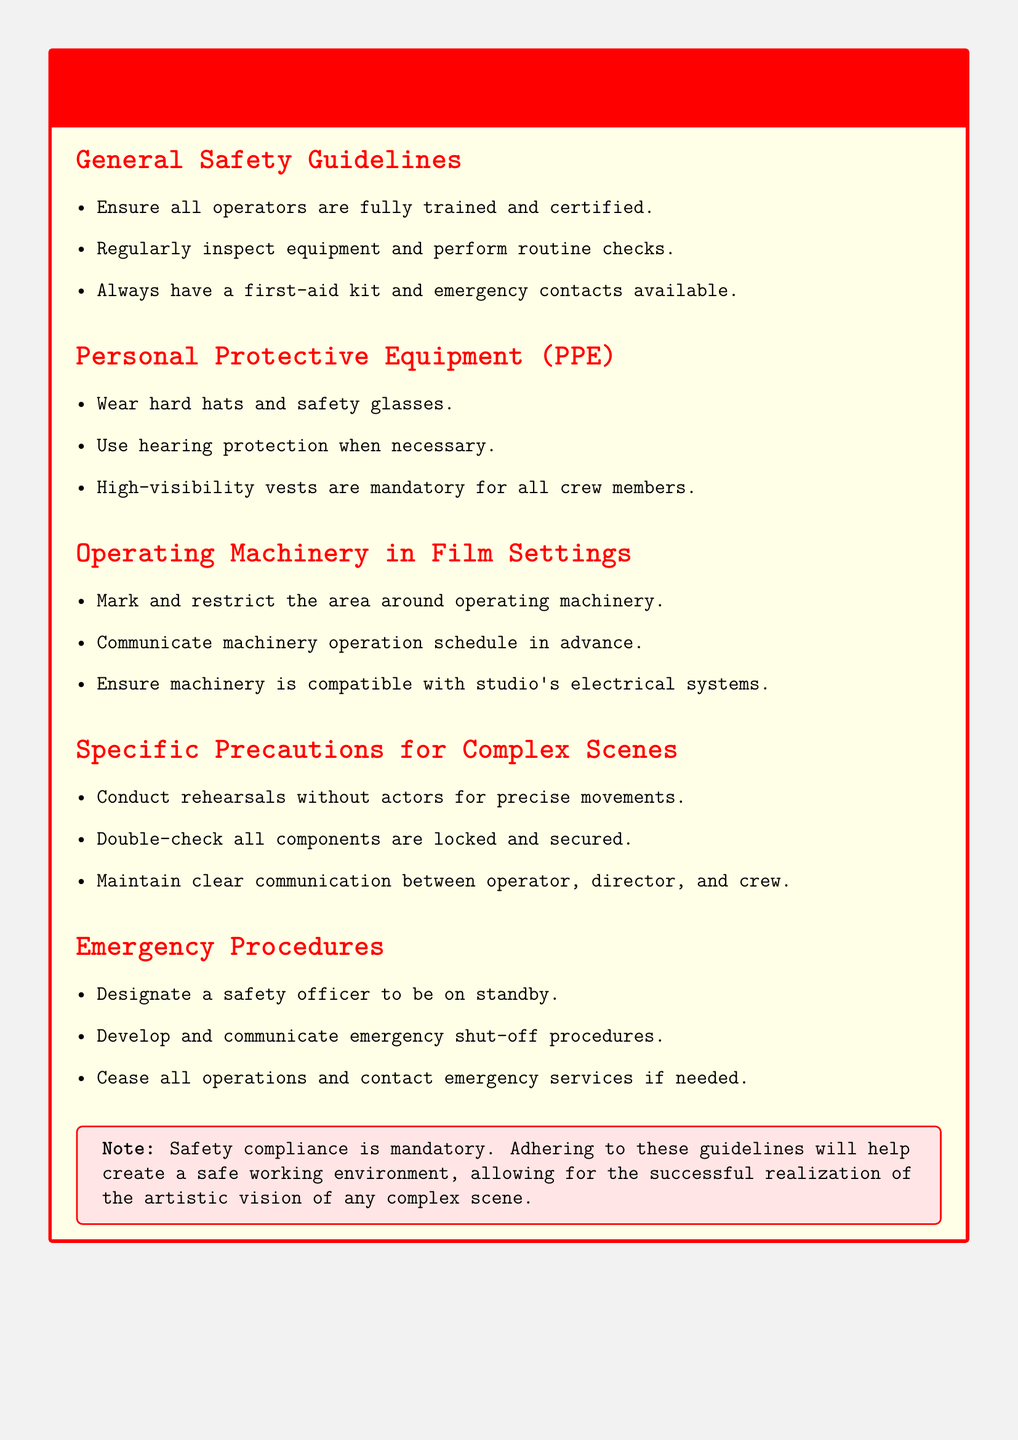what is the color of the warning box title? The title of the warning box is in red color, as stated in the document’s formatting.
Answer: red how many general safety guidelines are listed? The document lists three general safety guidelines in the relevant section.
Answer: 3 what type of protective equipment is mandatory for crew members? The document specifies high-visibility vests as mandatory for all crew members.
Answer: high-visibility vests who should be on standby in emergency procedures? The document states that a safety officer should be designated to be on standby.
Answer: safety officer what should operators ensure about machinery's compatibility? Operators should ensure that machinery is compatible with the studio's electrical systems.
Answer: compatible with studio's electrical systems what is a critical action to take during complex scene preparations? The document emphasizes the importance of conducting rehearsals without actors for precise movements.
Answer: rehearsals without actors how is communication supposed to be maintained among crew during operations? The document advises maintaining clear communication between the operator, director, and crew.
Answer: clear communication what is mandatory according to the note at the bottom of the document? The note in the document states that compliance with safety is mandatory for a safe working environment.
Answer: safety compliance 